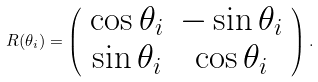<formula> <loc_0><loc_0><loc_500><loc_500>R ( \theta _ { i } ) = \left ( \begin{array} { c c } \cos \theta _ { i } & - \sin \theta _ { i } \\ \sin \theta _ { i } & \cos \theta _ { i } \\ \end{array} \right ) .</formula> 